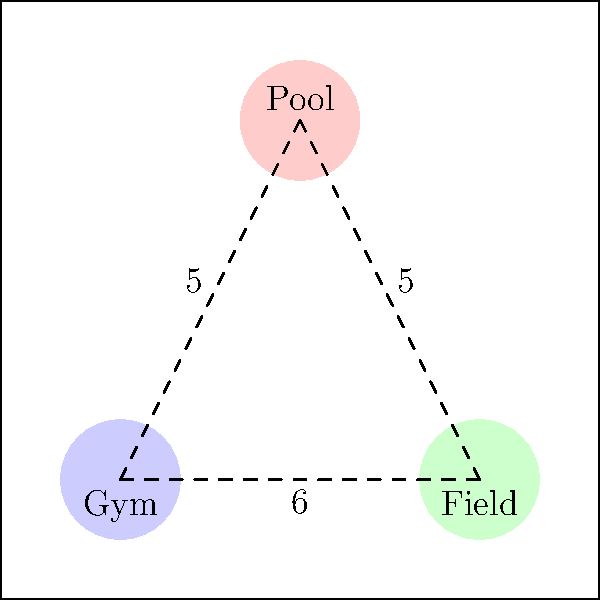A sports complex is planning to build three facilities: a gym, a field, and a pool. The diagram shows their proposed locations on a 10x10 plot. If the cost of utilities and pathways is proportional to the distance between facilities, how can the total distance between all facilities be minimized while keeping each facility at least 2 units away from the plot borders? To minimize the total distance between facilities while maintaining the border constraint, we need to follow these steps:

1. Recognize the current layout:
   - Gym at (2,2)
   - Field at (8,2)
   - Pool at (5,8)

2. Calculate the current total distance:
   - Gym to Field: 6 units
   - Gym to Pool: 5 units
   - Field to Pool: 5 units
   - Total: 6 + 5 + 5 = 16 units

3. Observe that the facilities form a triangle. The optimal solution to minimize the total distance between three points is to form an equilateral triangle.

4. Consider the border constraint:
   - Each facility must be at least 2 units away from the borders
   - This creates a 6x6 area in the center of the plot (from (2,2) to (8,8))

5. Place the facilities to form an equilateral triangle within this 6x6 area:
   - Gym: move to (3,3)
   - Field: move to (7,3)
   - Pool: move to (5,7)

6. Calculate the new distances:
   - The side length of this equilateral triangle is approximately 4.62 units
   - Total new distance: 3 * 4.62 ≈ 13.86 units

7. Verify the border constraint:
   - All facilities are now at least 2 units away from the plot borders

This new arrangement reduces the total distance from 16 units to approximately 13.86 units, while satisfying the border constraint.
Answer: Equilateral triangle with vertices at (3,3), (7,3), and (5,7) 